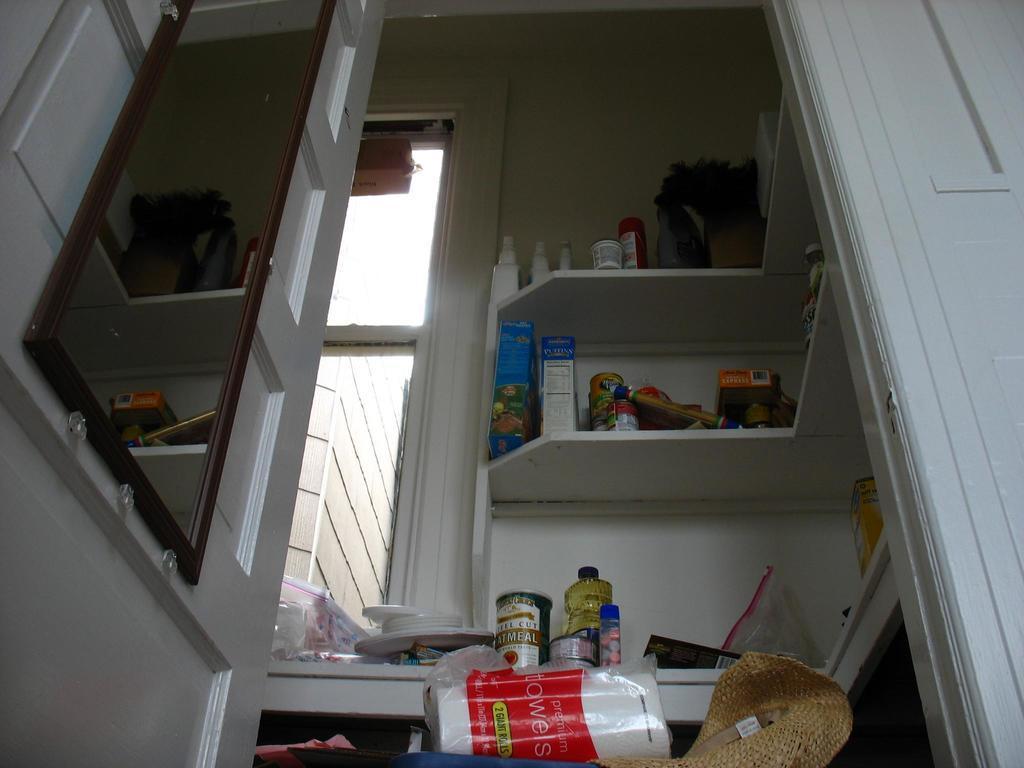Could you give a brief overview of what you see in this image? In this image we can see an inside view of a room, there are objects towards the bottom of the image, there is an object that looks like a table, there are objects on the table, there are shelves, there are objects on the shelves, there is a wall towards the top of the image, there is a wall towards the right of the image, there are windows, there is a wall towards the left of the image, there is a mirror on the wall. 